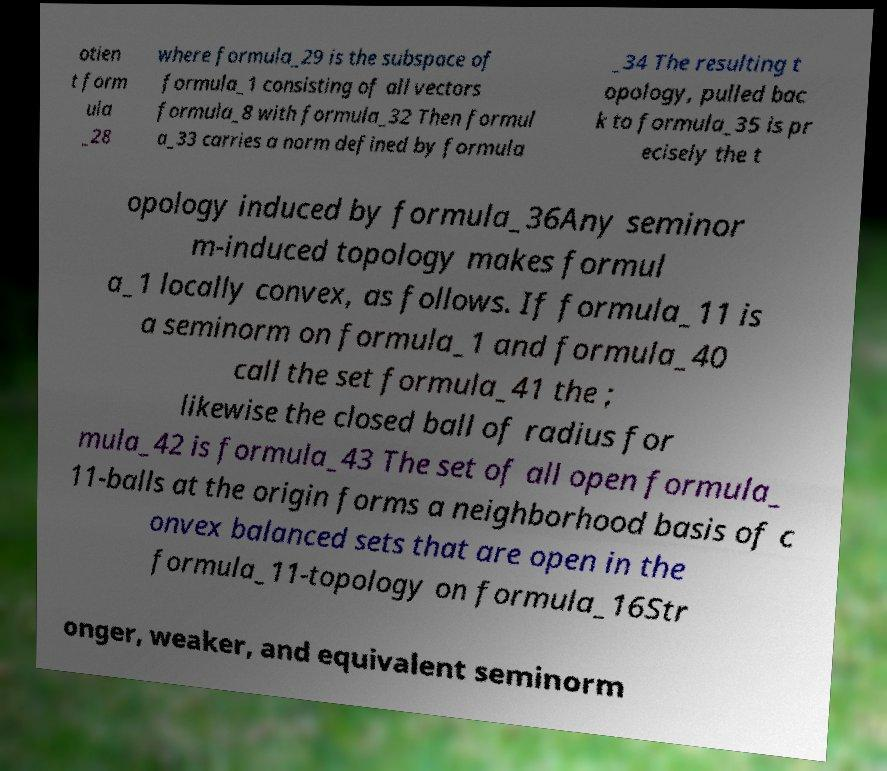Please read and relay the text visible in this image. What does it say? otien t form ula _28 where formula_29 is the subspace of formula_1 consisting of all vectors formula_8 with formula_32 Then formul a_33 carries a norm defined by formula _34 The resulting t opology, pulled bac k to formula_35 is pr ecisely the t opology induced by formula_36Any seminor m-induced topology makes formul a_1 locally convex, as follows. If formula_11 is a seminorm on formula_1 and formula_40 call the set formula_41 the ; likewise the closed ball of radius for mula_42 is formula_43 The set of all open formula_ 11-balls at the origin forms a neighborhood basis of c onvex balanced sets that are open in the formula_11-topology on formula_16Str onger, weaker, and equivalent seminorm 